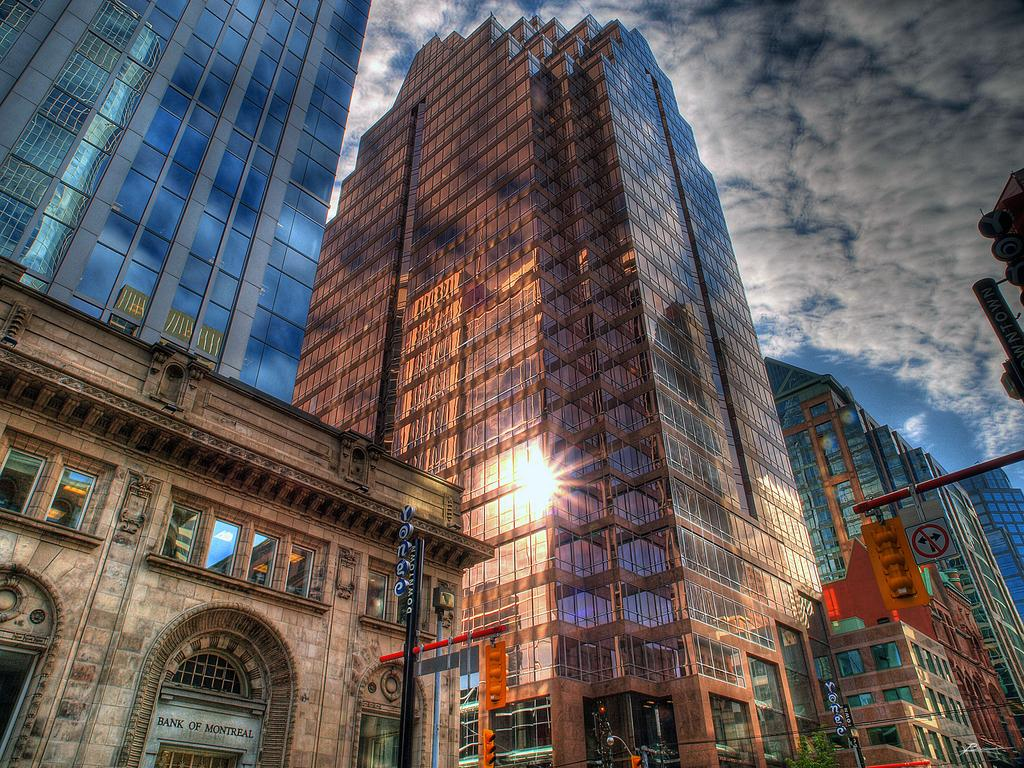What type of structures can be seen in the image? There are buildings in the image. What else can be seen in the image besides buildings? There are poles and traffic lights in the image. What is visible in the background of the image? The sky is visible in the background of the image. What channel can be seen on the television in the image? There is no television present in the image, so it is not possible to determine what channel might be on. 